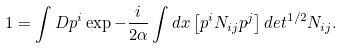Convert formula to latex. <formula><loc_0><loc_0><loc_500><loc_500>1 = \int D p ^ { i } \exp - \frac { i } { 2 \alpha } \int d x \left [ p ^ { i } N _ { i j } p ^ { j } \right ] d e t ^ { 1 / 2 } N _ { i j } .</formula> 